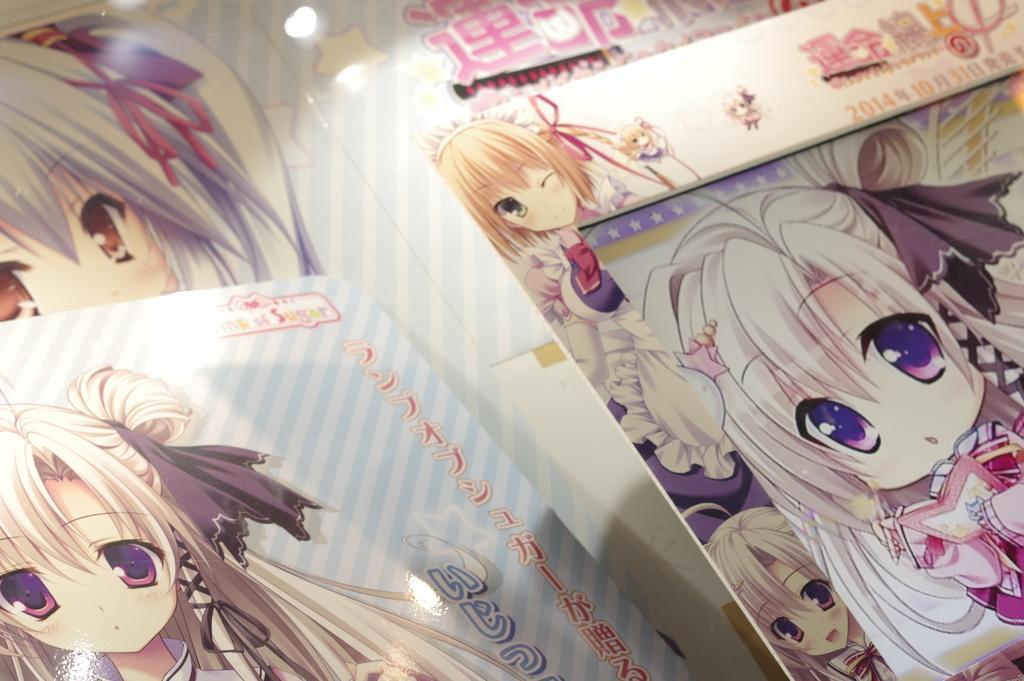How would you summarize this image in a sentence or two? On the right side there is a photo frame of an animated image. On the left side there is an animated character. 